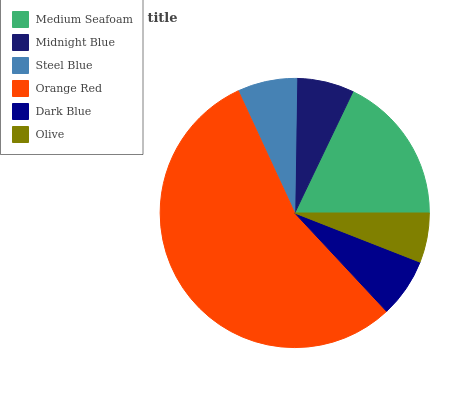Is Olive the minimum?
Answer yes or no. Yes. Is Orange Red the maximum?
Answer yes or no. Yes. Is Midnight Blue the minimum?
Answer yes or no. No. Is Midnight Blue the maximum?
Answer yes or no. No. Is Medium Seafoam greater than Midnight Blue?
Answer yes or no. Yes. Is Midnight Blue less than Medium Seafoam?
Answer yes or no. Yes. Is Midnight Blue greater than Medium Seafoam?
Answer yes or no. No. Is Medium Seafoam less than Midnight Blue?
Answer yes or no. No. Is Steel Blue the high median?
Answer yes or no. Yes. Is Dark Blue the low median?
Answer yes or no. Yes. Is Midnight Blue the high median?
Answer yes or no. No. Is Orange Red the low median?
Answer yes or no. No. 